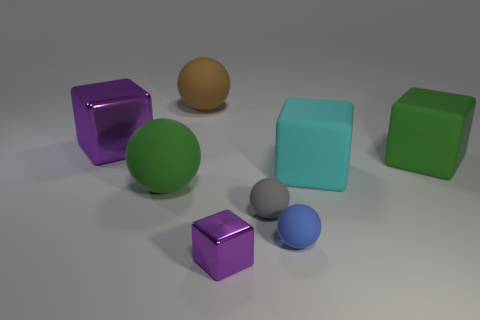Are any tiny gray rubber blocks visible?
Keep it short and to the point. No. There is a small metal thing; is it the same color as the metallic thing that is behind the small cube?
Offer a terse response. Yes. There is a gray rubber ball that is behind the purple object that is on the right side of the purple cube to the left of the small purple object; how big is it?
Your answer should be very brief. Small. How many other metallic cubes are the same color as the small cube?
Offer a very short reply. 1. What number of objects are large brown metal balls or green things that are right of the cyan block?
Make the answer very short. 1. The large metal cube has what color?
Your answer should be very brief. Purple. There is a big rubber ball that is in front of the big metal block; what is its color?
Give a very brief answer. Green. What number of small gray spheres are on the left side of the purple metal cube to the left of the small cube?
Your answer should be compact. 0. There is a cyan object; is its size the same as the sphere behind the green rubber sphere?
Give a very brief answer. Yes. Is there a brown matte ball of the same size as the green sphere?
Offer a terse response. Yes. 